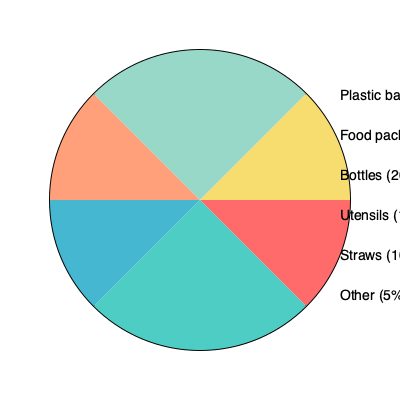Based on the pie chart showing the distribution of single-use plastic waste in the community, which two categories combined account for more than half of the total plastic waste? To determine which two categories combined account for more than half of the total plastic waste, we need to follow these steps:

1. Identify the percentages for each category:
   - Plastic bags: 30%
   - Food packaging: 25%
   - Bottles: 20%
   - Utensils: 10%
   - Straws: 10%
   - Other: 5%

2. Find the two largest percentages:
   - The largest is plastic bags at 30%
   - The second largest is food packaging at 25%

3. Add these two percentages:
   $30\% + 25\% = 55\%$

4. Check if the sum is greater than 50%:
   $55\% > 50\%$

Therefore, plastic bags and food packaging combined account for 55% of the total plastic waste, which is more than half.
Answer: Plastic bags and food packaging 